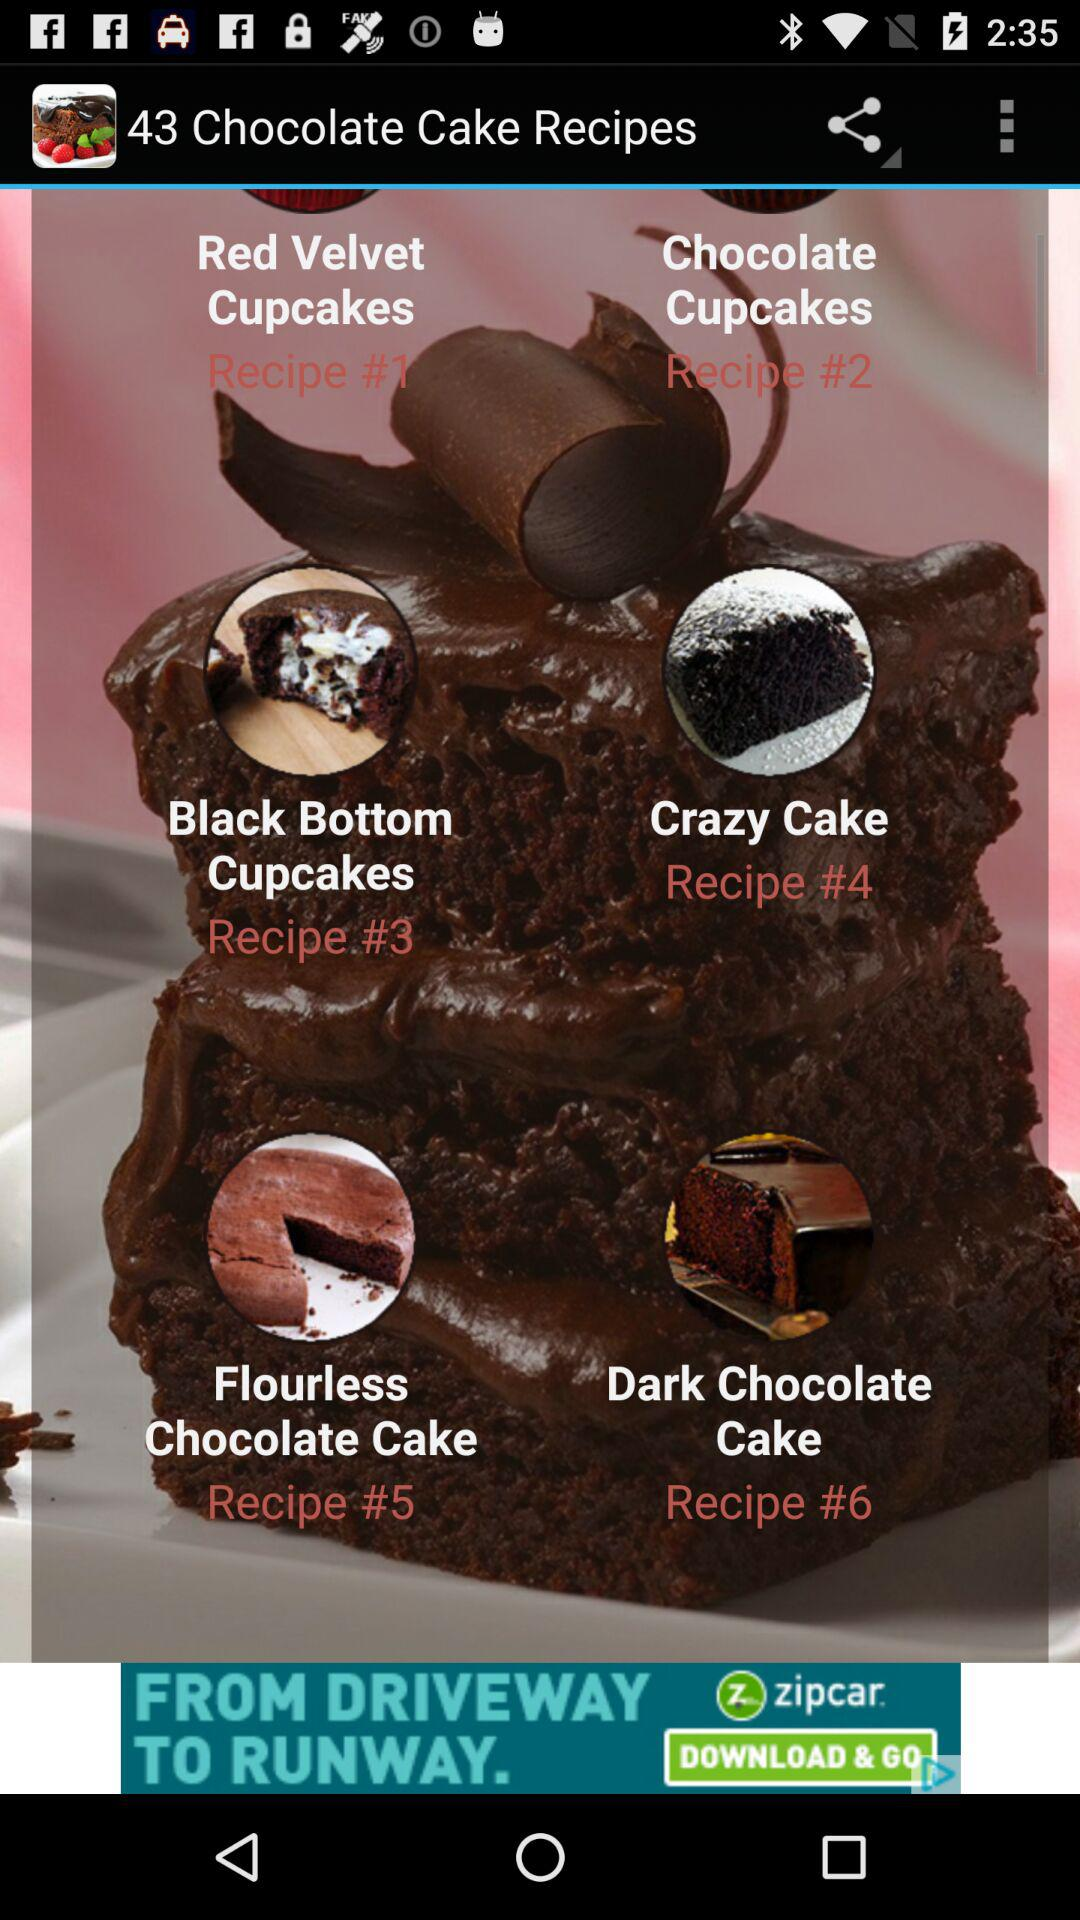How many chocolate cakes are pictured on the screen?
Answer the question using a single word or phrase. 4 